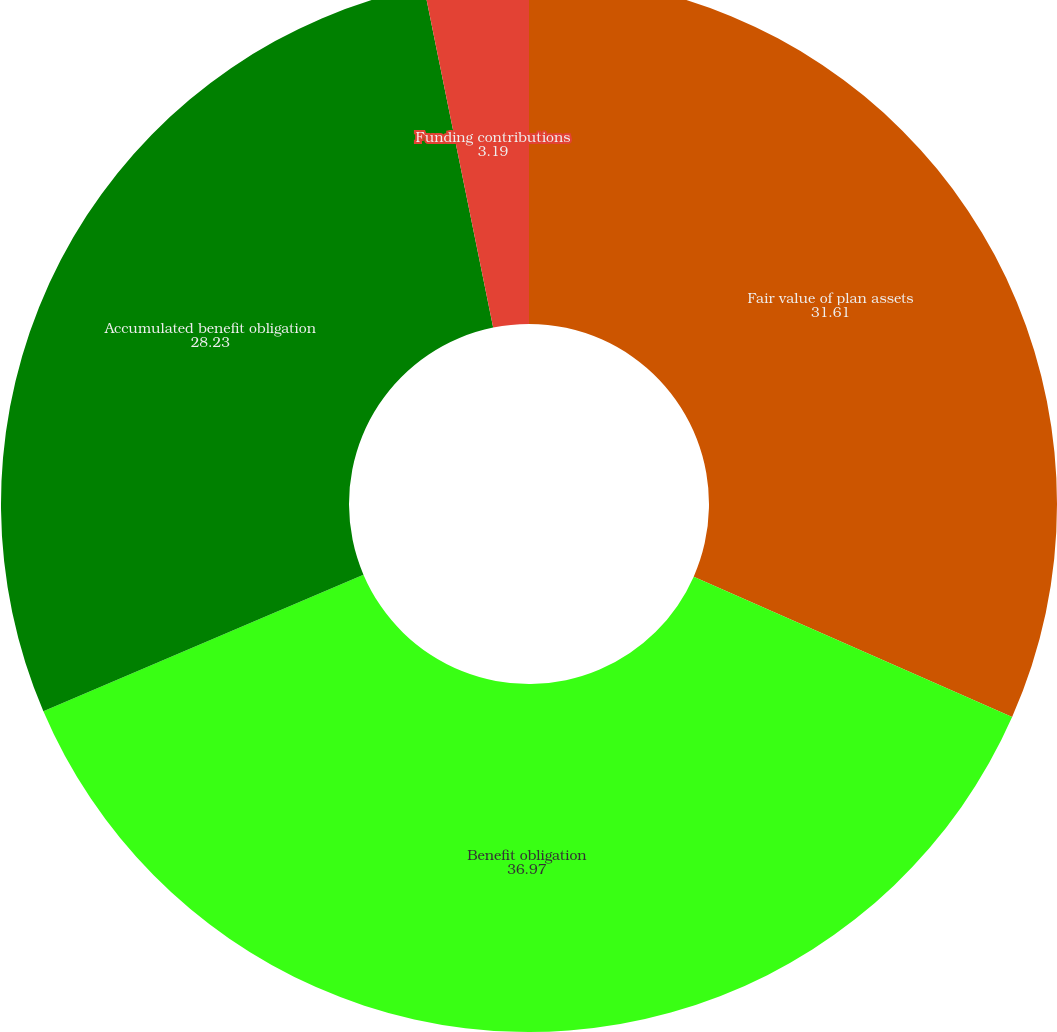Convert chart to OTSL. <chart><loc_0><loc_0><loc_500><loc_500><pie_chart><fcel>Fair value of plan assets<fcel>Benefit obligation<fcel>Accumulated benefit obligation<fcel>Funding contributions<nl><fcel>31.61%<fcel>36.97%<fcel>28.23%<fcel>3.19%<nl></chart> 